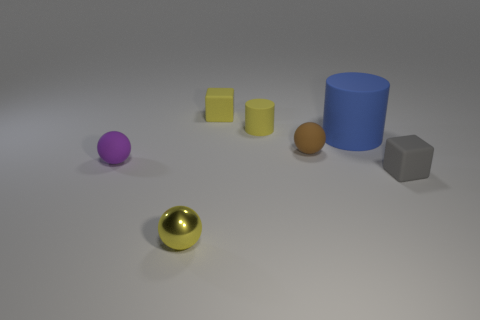There is a yellow thing that is the same shape as the purple thing; what material is it?
Offer a terse response. Metal. Are there any other things that have the same size as the shiny ball?
Your answer should be compact. Yes. How big is the ball that is right of the tiny yellow object that is in front of the large object?
Offer a terse response. Small. The big rubber cylinder is what color?
Your answer should be compact. Blue. What number of small brown things are in front of the small cube that is right of the tiny yellow cylinder?
Offer a terse response. 0. Is there a tiny ball that is on the right side of the small rubber thing that is to the right of the blue rubber cylinder?
Your response must be concise. No. Are there any big matte things behind the big blue cylinder?
Your answer should be very brief. No. There is a thing that is to the left of the yellow shiny object; does it have the same shape as the gray matte thing?
Offer a terse response. No. What number of blue things are the same shape as the small purple rubber object?
Your response must be concise. 0. Is there a brown ball made of the same material as the purple ball?
Your answer should be compact. Yes. 